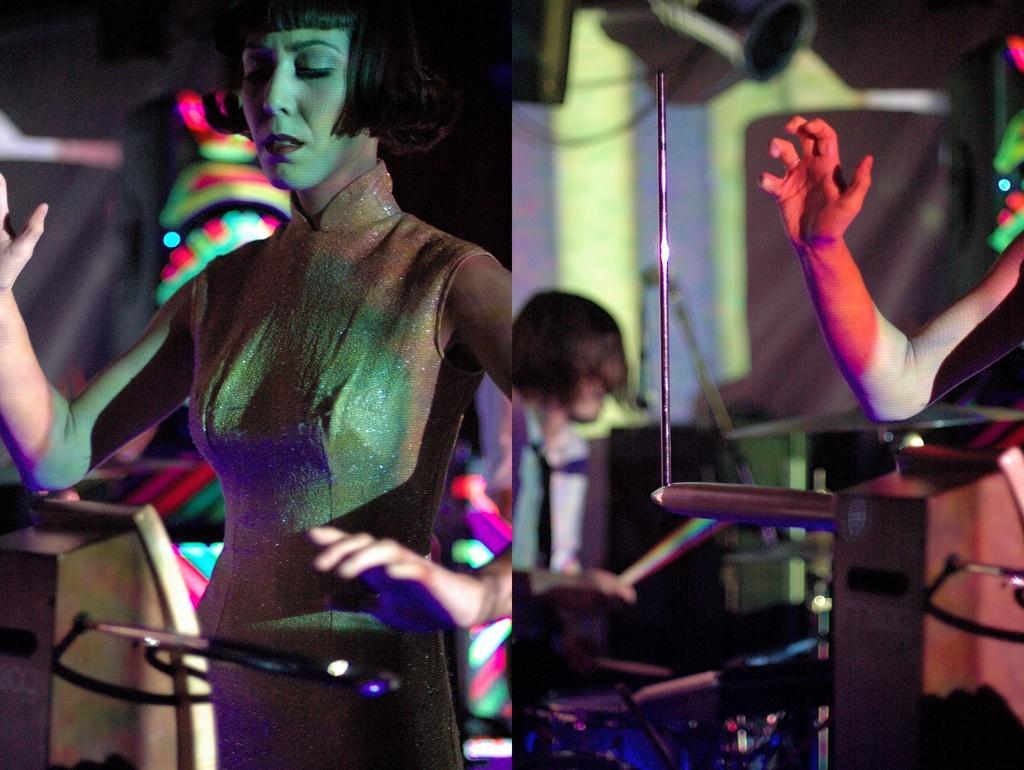How would you summarize this image in a sentence or two? This is a collage image, in this image there is a women standing in front of an object, in other image a person sitting on chair and on the left side there is a hand. 